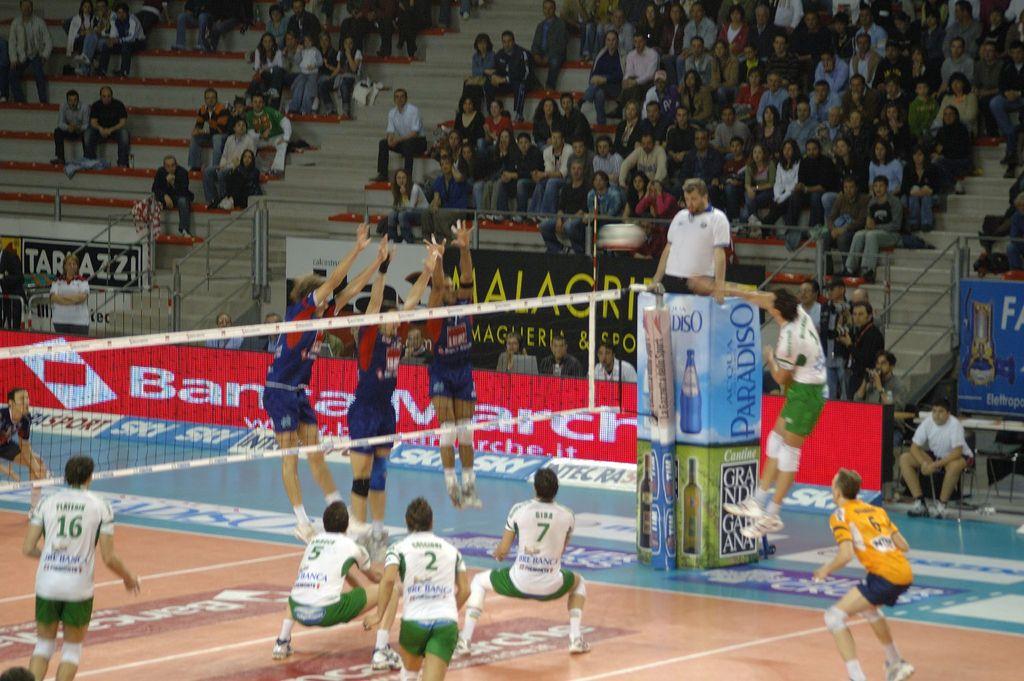What sport are they playing?
Your answer should be very brief. Answering does not require reading text in the image. What number is the player in yellow?
Give a very brief answer. 6. 